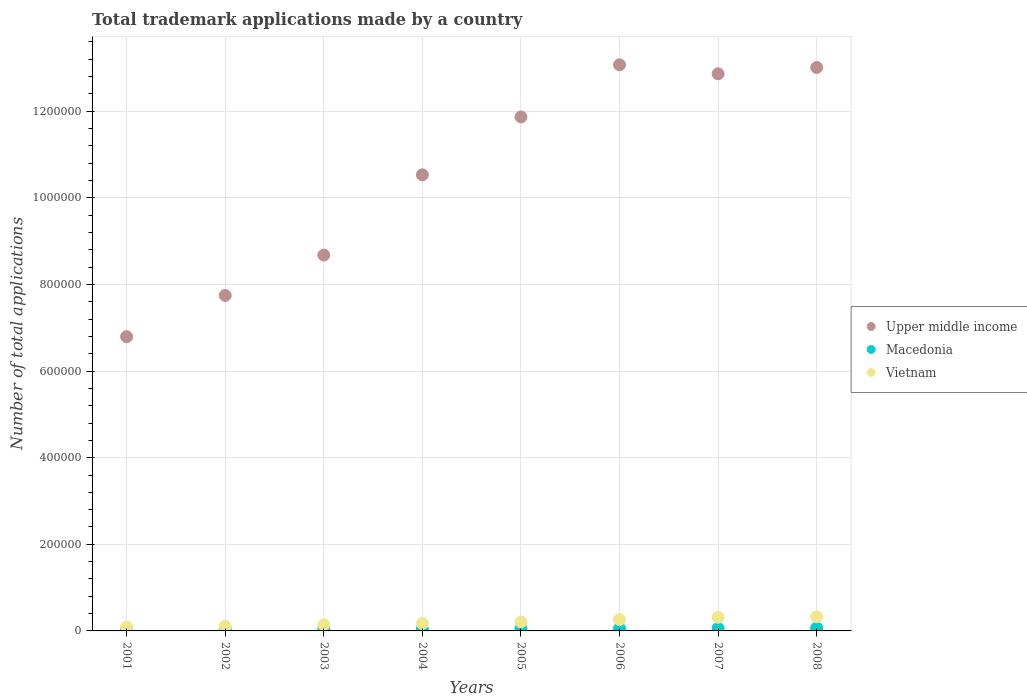How many different coloured dotlines are there?
Your answer should be very brief. 3. What is the number of applications made by in Upper middle income in 2001?
Give a very brief answer. 6.79e+05. Across all years, what is the maximum number of applications made by in Macedonia?
Offer a terse response. 6856. Across all years, what is the minimum number of applications made by in Macedonia?
Offer a very short reply. 3952. In which year was the number of applications made by in Vietnam maximum?
Keep it short and to the point. 2008. What is the total number of applications made by in Upper middle income in the graph?
Make the answer very short. 8.46e+06. What is the difference between the number of applications made by in Upper middle income in 2002 and that in 2003?
Offer a terse response. -9.32e+04. What is the difference between the number of applications made by in Macedonia in 2006 and the number of applications made by in Upper middle income in 2004?
Make the answer very short. -1.05e+06. What is the average number of applications made by in Macedonia per year?
Offer a terse response. 5102.62. In the year 2006, what is the difference between the number of applications made by in Macedonia and number of applications made by in Upper middle income?
Your response must be concise. -1.30e+06. What is the ratio of the number of applications made by in Vietnam in 2001 to that in 2005?
Your answer should be very brief. 0.42. Is the number of applications made by in Macedonia in 2001 less than that in 2006?
Provide a short and direct response. Yes. What is the difference between the highest and the second highest number of applications made by in Macedonia?
Make the answer very short. 905. What is the difference between the highest and the lowest number of applications made by in Macedonia?
Give a very brief answer. 2904. In how many years, is the number of applications made by in Vietnam greater than the average number of applications made by in Vietnam taken over all years?
Offer a terse response. 4. Is the number of applications made by in Upper middle income strictly greater than the number of applications made by in Macedonia over the years?
Give a very brief answer. Yes. How many years are there in the graph?
Your response must be concise. 8. Are the values on the major ticks of Y-axis written in scientific E-notation?
Offer a terse response. No. Does the graph contain any zero values?
Give a very brief answer. No. How many legend labels are there?
Offer a terse response. 3. What is the title of the graph?
Your answer should be compact. Total trademark applications made by a country. Does "Philippines" appear as one of the legend labels in the graph?
Give a very brief answer. No. What is the label or title of the Y-axis?
Offer a very short reply. Number of total applications. What is the Number of total applications in Upper middle income in 2001?
Your response must be concise. 6.79e+05. What is the Number of total applications of Macedonia in 2001?
Your answer should be compact. 4402. What is the Number of total applications of Vietnam in 2001?
Make the answer very short. 8767. What is the Number of total applications in Upper middle income in 2002?
Provide a succinct answer. 7.75e+05. What is the Number of total applications of Macedonia in 2002?
Give a very brief answer. 3952. What is the Number of total applications of Vietnam in 2002?
Provide a short and direct response. 1.07e+04. What is the Number of total applications in Upper middle income in 2003?
Offer a terse response. 8.68e+05. What is the Number of total applications of Macedonia in 2003?
Provide a succinct answer. 4346. What is the Number of total applications of Vietnam in 2003?
Your answer should be compact. 1.42e+04. What is the Number of total applications of Upper middle income in 2004?
Make the answer very short. 1.05e+06. What is the Number of total applications in Macedonia in 2004?
Keep it short and to the point. 4402. What is the Number of total applications of Vietnam in 2004?
Offer a very short reply. 1.72e+04. What is the Number of total applications in Upper middle income in 2005?
Keep it short and to the point. 1.19e+06. What is the Number of total applications in Macedonia in 2005?
Give a very brief answer. 5397. What is the Number of total applications of Vietnam in 2005?
Give a very brief answer. 2.07e+04. What is the Number of total applications of Upper middle income in 2006?
Keep it short and to the point. 1.31e+06. What is the Number of total applications of Macedonia in 2006?
Offer a very short reply. 5515. What is the Number of total applications of Vietnam in 2006?
Provide a succinct answer. 2.61e+04. What is the Number of total applications of Upper middle income in 2007?
Give a very brief answer. 1.29e+06. What is the Number of total applications in Macedonia in 2007?
Give a very brief answer. 5951. What is the Number of total applications of Vietnam in 2007?
Keep it short and to the point. 3.15e+04. What is the Number of total applications of Upper middle income in 2008?
Offer a terse response. 1.30e+06. What is the Number of total applications of Macedonia in 2008?
Ensure brevity in your answer.  6856. What is the Number of total applications of Vietnam in 2008?
Give a very brief answer. 3.27e+04. Across all years, what is the maximum Number of total applications of Upper middle income?
Your answer should be very brief. 1.31e+06. Across all years, what is the maximum Number of total applications of Macedonia?
Your answer should be very brief. 6856. Across all years, what is the maximum Number of total applications in Vietnam?
Provide a succinct answer. 3.27e+04. Across all years, what is the minimum Number of total applications of Upper middle income?
Your answer should be compact. 6.79e+05. Across all years, what is the minimum Number of total applications in Macedonia?
Make the answer very short. 3952. Across all years, what is the minimum Number of total applications in Vietnam?
Ensure brevity in your answer.  8767. What is the total Number of total applications in Upper middle income in the graph?
Offer a terse response. 8.46e+06. What is the total Number of total applications in Macedonia in the graph?
Make the answer very short. 4.08e+04. What is the total Number of total applications of Vietnam in the graph?
Your response must be concise. 1.62e+05. What is the difference between the Number of total applications in Upper middle income in 2001 and that in 2002?
Offer a terse response. -9.53e+04. What is the difference between the Number of total applications of Macedonia in 2001 and that in 2002?
Ensure brevity in your answer.  450. What is the difference between the Number of total applications of Vietnam in 2001 and that in 2002?
Your answer should be compact. -1980. What is the difference between the Number of total applications of Upper middle income in 2001 and that in 2003?
Give a very brief answer. -1.88e+05. What is the difference between the Number of total applications of Macedonia in 2001 and that in 2003?
Make the answer very short. 56. What is the difference between the Number of total applications in Vietnam in 2001 and that in 2003?
Your answer should be very brief. -5436. What is the difference between the Number of total applications of Upper middle income in 2001 and that in 2004?
Provide a succinct answer. -3.74e+05. What is the difference between the Number of total applications in Macedonia in 2001 and that in 2004?
Offer a terse response. 0. What is the difference between the Number of total applications in Vietnam in 2001 and that in 2004?
Your answer should be very brief. -8408. What is the difference between the Number of total applications in Upper middle income in 2001 and that in 2005?
Your response must be concise. -5.07e+05. What is the difference between the Number of total applications of Macedonia in 2001 and that in 2005?
Make the answer very short. -995. What is the difference between the Number of total applications in Vietnam in 2001 and that in 2005?
Keep it short and to the point. -1.19e+04. What is the difference between the Number of total applications of Upper middle income in 2001 and that in 2006?
Keep it short and to the point. -6.28e+05. What is the difference between the Number of total applications in Macedonia in 2001 and that in 2006?
Your response must be concise. -1113. What is the difference between the Number of total applications in Vietnam in 2001 and that in 2006?
Make the answer very short. -1.74e+04. What is the difference between the Number of total applications in Upper middle income in 2001 and that in 2007?
Give a very brief answer. -6.07e+05. What is the difference between the Number of total applications of Macedonia in 2001 and that in 2007?
Provide a short and direct response. -1549. What is the difference between the Number of total applications in Vietnam in 2001 and that in 2007?
Make the answer very short. -2.27e+04. What is the difference between the Number of total applications in Upper middle income in 2001 and that in 2008?
Provide a short and direct response. -6.22e+05. What is the difference between the Number of total applications in Macedonia in 2001 and that in 2008?
Your response must be concise. -2454. What is the difference between the Number of total applications in Vietnam in 2001 and that in 2008?
Offer a terse response. -2.39e+04. What is the difference between the Number of total applications of Upper middle income in 2002 and that in 2003?
Offer a terse response. -9.32e+04. What is the difference between the Number of total applications of Macedonia in 2002 and that in 2003?
Your response must be concise. -394. What is the difference between the Number of total applications in Vietnam in 2002 and that in 2003?
Your answer should be compact. -3456. What is the difference between the Number of total applications of Upper middle income in 2002 and that in 2004?
Provide a succinct answer. -2.78e+05. What is the difference between the Number of total applications of Macedonia in 2002 and that in 2004?
Offer a very short reply. -450. What is the difference between the Number of total applications of Vietnam in 2002 and that in 2004?
Give a very brief answer. -6428. What is the difference between the Number of total applications in Upper middle income in 2002 and that in 2005?
Your response must be concise. -4.12e+05. What is the difference between the Number of total applications in Macedonia in 2002 and that in 2005?
Make the answer very short. -1445. What is the difference between the Number of total applications of Vietnam in 2002 and that in 2005?
Offer a terse response. -9916. What is the difference between the Number of total applications in Upper middle income in 2002 and that in 2006?
Offer a very short reply. -5.33e+05. What is the difference between the Number of total applications of Macedonia in 2002 and that in 2006?
Ensure brevity in your answer.  -1563. What is the difference between the Number of total applications in Vietnam in 2002 and that in 2006?
Offer a very short reply. -1.54e+04. What is the difference between the Number of total applications in Upper middle income in 2002 and that in 2007?
Provide a short and direct response. -5.12e+05. What is the difference between the Number of total applications of Macedonia in 2002 and that in 2007?
Offer a very short reply. -1999. What is the difference between the Number of total applications of Vietnam in 2002 and that in 2007?
Make the answer very short. -2.08e+04. What is the difference between the Number of total applications in Upper middle income in 2002 and that in 2008?
Make the answer very short. -5.26e+05. What is the difference between the Number of total applications of Macedonia in 2002 and that in 2008?
Your response must be concise. -2904. What is the difference between the Number of total applications of Vietnam in 2002 and that in 2008?
Offer a very short reply. -2.19e+04. What is the difference between the Number of total applications in Upper middle income in 2003 and that in 2004?
Your answer should be compact. -1.85e+05. What is the difference between the Number of total applications of Macedonia in 2003 and that in 2004?
Provide a short and direct response. -56. What is the difference between the Number of total applications in Vietnam in 2003 and that in 2004?
Give a very brief answer. -2972. What is the difference between the Number of total applications in Upper middle income in 2003 and that in 2005?
Keep it short and to the point. -3.19e+05. What is the difference between the Number of total applications of Macedonia in 2003 and that in 2005?
Keep it short and to the point. -1051. What is the difference between the Number of total applications of Vietnam in 2003 and that in 2005?
Ensure brevity in your answer.  -6460. What is the difference between the Number of total applications in Upper middle income in 2003 and that in 2006?
Offer a terse response. -4.39e+05. What is the difference between the Number of total applications in Macedonia in 2003 and that in 2006?
Provide a succinct answer. -1169. What is the difference between the Number of total applications in Vietnam in 2003 and that in 2006?
Your answer should be very brief. -1.19e+04. What is the difference between the Number of total applications in Upper middle income in 2003 and that in 2007?
Offer a terse response. -4.19e+05. What is the difference between the Number of total applications in Macedonia in 2003 and that in 2007?
Your response must be concise. -1605. What is the difference between the Number of total applications in Vietnam in 2003 and that in 2007?
Offer a very short reply. -1.73e+04. What is the difference between the Number of total applications of Upper middle income in 2003 and that in 2008?
Provide a short and direct response. -4.33e+05. What is the difference between the Number of total applications in Macedonia in 2003 and that in 2008?
Your answer should be very brief. -2510. What is the difference between the Number of total applications of Vietnam in 2003 and that in 2008?
Your answer should be very brief. -1.85e+04. What is the difference between the Number of total applications of Upper middle income in 2004 and that in 2005?
Give a very brief answer. -1.34e+05. What is the difference between the Number of total applications of Macedonia in 2004 and that in 2005?
Offer a very short reply. -995. What is the difference between the Number of total applications of Vietnam in 2004 and that in 2005?
Give a very brief answer. -3488. What is the difference between the Number of total applications of Upper middle income in 2004 and that in 2006?
Give a very brief answer. -2.54e+05. What is the difference between the Number of total applications of Macedonia in 2004 and that in 2006?
Make the answer very short. -1113. What is the difference between the Number of total applications of Vietnam in 2004 and that in 2006?
Make the answer very short. -8965. What is the difference between the Number of total applications of Upper middle income in 2004 and that in 2007?
Your answer should be very brief. -2.33e+05. What is the difference between the Number of total applications of Macedonia in 2004 and that in 2007?
Make the answer very short. -1549. What is the difference between the Number of total applications in Vietnam in 2004 and that in 2007?
Make the answer very short. -1.43e+04. What is the difference between the Number of total applications in Upper middle income in 2004 and that in 2008?
Your answer should be very brief. -2.48e+05. What is the difference between the Number of total applications in Macedonia in 2004 and that in 2008?
Your answer should be compact. -2454. What is the difference between the Number of total applications of Vietnam in 2004 and that in 2008?
Your answer should be compact. -1.55e+04. What is the difference between the Number of total applications in Upper middle income in 2005 and that in 2006?
Offer a terse response. -1.20e+05. What is the difference between the Number of total applications in Macedonia in 2005 and that in 2006?
Offer a terse response. -118. What is the difference between the Number of total applications in Vietnam in 2005 and that in 2006?
Offer a terse response. -5477. What is the difference between the Number of total applications in Upper middle income in 2005 and that in 2007?
Offer a very short reply. -9.96e+04. What is the difference between the Number of total applications of Macedonia in 2005 and that in 2007?
Ensure brevity in your answer.  -554. What is the difference between the Number of total applications in Vietnam in 2005 and that in 2007?
Your answer should be very brief. -1.08e+04. What is the difference between the Number of total applications in Upper middle income in 2005 and that in 2008?
Keep it short and to the point. -1.14e+05. What is the difference between the Number of total applications in Macedonia in 2005 and that in 2008?
Provide a succinct answer. -1459. What is the difference between the Number of total applications in Vietnam in 2005 and that in 2008?
Ensure brevity in your answer.  -1.20e+04. What is the difference between the Number of total applications in Upper middle income in 2006 and that in 2007?
Your answer should be very brief. 2.08e+04. What is the difference between the Number of total applications in Macedonia in 2006 and that in 2007?
Ensure brevity in your answer.  -436. What is the difference between the Number of total applications of Vietnam in 2006 and that in 2007?
Offer a terse response. -5357. What is the difference between the Number of total applications of Upper middle income in 2006 and that in 2008?
Offer a terse response. 6140. What is the difference between the Number of total applications in Macedonia in 2006 and that in 2008?
Your answer should be very brief. -1341. What is the difference between the Number of total applications of Vietnam in 2006 and that in 2008?
Your response must be concise. -6544. What is the difference between the Number of total applications in Upper middle income in 2007 and that in 2008?
Offer a terse response. -1.46e+04. What is the difference between the Number of total applications in Macedonia in 2007 and that in 2008?
Ensure brevity in your answer.  -905. What is the difference between the Number of total applications of Vietnam in 2007 and that in 2008?
Offer a terse response. -1187. What is the difference between the Number of total applications of Upper middle income in 2001 and the Number of total applications of Macedonia in 2002?
Provide a short and direct response. 6.75e+05. What is the difference between the Number of total applications in Upper middle income in 2001 and the Number of total applications in Vietnam in 2002?
Ensure brevity in your answer.  6.69e+05. What is the difference between the Number of total applications of Macedonia in 2001 and the Number of total applications of Vietnam in 2002?
Provide a short and direct response. -6345. What is the difference between the Number of total applications in Upper middle income in 2001 and the Number of total applications in Macedonia in 2003?
Ensure brevity in your answer.  6.75e+05. What is the difference between the Number of total applications in Upper middle income in 2001 and the Number of total applications in Vietnam in 2003?
Offer a terse response. 6.65e+05. What is the difference between the Number of total applications in Macedonia in 2001 and the Number of total applications in Vietnam in 2003?
Offer a terse response. -9801. What is the difference between the Number of total applications in Upper middle income in 2001 and the Number of total applications in Macedonia in 2004?
Keep it short and to the point. 6.75e+05. What is the difference between the Number of total applications in Upper middle income in 2001 and the Number of total applications in Vietnam in 2004?
Offer a very short reply. 6.62e+05. What is the difference between the Number of total applications of Macedonia in 2001 and the Number of total applications of Vietnam in 2004?
Give a very brief answer. -1.28e+04. What is the difference between the Number of total applications in Upper middle income in 2001 and the Number of total applications in Macedonia in 2005?
Keep it short and to the point. 6.74e+05. What is the difference between the Number of total applications of Upper middle income in 2001 and the Number of total applications of Vietnam in 2005?
Offer a terse response. 6.59e+05. What is the difference between the Number of total applications of Macedonia in 2001 and the Number of total applications of Vietnam in 2005?
Ensure brevity in your answer.  -1.63e+04. What is the difference between the Number of total applications in Upper middle income in 2001 and the Number of total applications in Macedonia in 2006?
Give a very brief answer. 6.74e+05. What is the difference between the Number of total applications of Upper middle income in 2001 and the Number of total applications of Vietnam in 2006?
Provide a short and direct response. 6.53e+05. What is the difference between the Number of total applications in Macedonia in 2001 and the Number of total applications in Vietnam in 2006?
Provide a short and direct response. -2.17e+04. What is the difference between the Number of total applications in Upper middle income in 2001 and the Number of total applications in Macedonia in 2007?
Your answer should be very brief. 6.73e+05. What is the difference between the Number of total applications of Upper middle income in 2001 and the Number of total applications of Vietnam in 2007?
Give a very brief answer. 6.48e+05. What is the difference between the Number of total applications in Macedonia in 2001 and the Number of total applications in Vietnam in 2007?
Your response must be concise. -2.71e+04. What is the difference between the Number of total applications of Upper middle income in 2001 and the Number of total applications of Macedonia in 2008?
Your response must be concise. 6.73e+05. What is the difference between the Number of total applications in Upper middle income in 2001 and the Number of total applications in Vietnam in 2008?
Ensure brevity in your answer.  6.47e+05. What is the difference between the Number of total applications of Macedonia in 2001 and the Number of total applications of Vietnam in 2008?
Keep it short and to the point. -2.83e+04. What is the difference between the Number of total applications in Upper middle income in 2002 and the Number of total applications in Macedonia in 2003?
Your answer should be compact. 7.70e+05. What is the difference between the Number of total applications of Upper middle income in 2002 and the Number of total applications of Vietnam in 2003?
Ensure brevity in your answer.  7.60e+05. What is the difference between the Number of total applications in Macedonia in 2002 and the Number of total applications in Vietnam in 2003?
Provide a succinct answer. -1.03e+04. What is the difference between the Number of total applications in Upper middle income in 2002 and the Number of total applications in Macedonia in 2004?
Keep it short and to the point. 7.70e+05. What is the difference between the Number of total applications of Upper middle income in 2002 and the Number of total applications of Vietnam in 2004?
Provide a succinct answer. 7.57e+05. What is the difference between the Number of total applications in Macedonia in 2002 and the Number of total applications in Vietnam in 2004?
Provide a succinct answer. -1.32e+04. What is the difference between the Number of total applications in Upper middle income in 2002 and the Number of total applications in Macedonia in 2005?
Provide a short and direct response. 7.69e+05. What is the difference between the Number of total applications of Upper middle income in 2002 and the Number of total applications of Vietnam in 2005?
Your answer should be very brief. 7.54e+05. What is the difference between the Number of total applications in Macedonia in 2002 and the Number of total applications in Vietnam in 2005?
Keep it short and to the point. -1.67e+04. What is the difference between the Number of total applications of Upper middle income in 2002 and the Number of total applications of Macedonia in 2006?
Your answer should be very brief. 7.69e+05. What is the difference between the Number of total applications in Upper middle income in 2002 and the Number of total applications in Vietnam in 2006?
Keep it short and to the point. 7.49e+05. What is the difference between the Number of total applications of Macedonia in 2002 and the Number of total applications of Vietnam in 2006?
Ensure brevity in your answer.  -2.22e+04. What is the difference between the Number of total applications of Upper middle income in 2002 and the Number of total applications of Macedonia in 2007?
Your response must be concise. 7.69e+05. What is the difference between the Number of total applications of Upper middle income in 2002 and the Number of total applications of Vietnam in 2007?
Your answer should be compact. 7.43e+05. What is the difference between the Number of total applications of Macedonia in 2002 and the Number of total applications of Vietnam in 2007?
Your response must be concise. -2.75e+04. What is the difference between the Number of total applications of Upper middle income in 2002 and the Number of total applications of Macedonia in 2008?
Give a very brief answer. 7.68e+05. What is the difference between the Number of total applications in Upper middle income in 2002 and the Number of total applications in Vietnam in 2008?
Keep it short and to the point. 7.42e+05. What is the difference between the Number of total applications of Macedonia in 2002 and the Number of total applications of Vietnam in 2008?
Your answer should be compact. -2.87e+04. What is the difference between the Number of total applications in Upper middle income in 2003 and the Number of total applications in Macedonia in 2004?
Your answer should be compact. 8.63e+05. What is the difference between the Number of total applications of Upper middle income in 2003 and the Number of total applications of Vietnam in 2004?
Give a very brief answer. 8.51e+05. What is the difference between the Number of total applications of Macedonia in 2003 and the Number of total applications of Vietnam in 2004?
Keep it short and to the point. -1.28e+04. What is the difference between the Number of total applications of Upper middle income in 2003 and the Number of total applications of Macedonia in 2005?
Keep it short and to the point. 8.62e+05. What is the difference between the Number of total applications of Upper middle income in 2003 and the Number of total applications of Vietnam in 2005?
Give a very brief answer. 8.47e+05. What is the difference between the Number of total applications in Macedonia in 2003 and the Number of total applications in Vietnam in 2005?
Offer a terse response. -1.63e+04. What is the difference between the Number of total applications in Upper middle income in 2003 and the Number of total applications in Macedonia in 2006?
Give a very brief answer. 8.62e+05. What is the difference between the Number of total applications in Upper middle income in 2003 and the Number of total applications in Vietnam in 2006?
Your response must be concise. 8.42e+05. What is the difference between the Number of total applications in Macedonia in 2003 and the Number of total applications in Vietnam in 2006?
Your response must be concise. -2.18e+04. What is the difference between the Number of total applications in Upper middle income in 2003 and the Number of total applications in Macedonia in 2007?
Provide a short and direct response. 8.62e+05. What is the difference between the Number of total applications in Upper middle income in 2003 and the Number of total applications in Vietnam in 2007?
Ensure brevity in your answer.  8.36e+05. What is the difference between the Number of total applications of Macedonia in 2003 and the Number of total applications of Vietnam in 2007?
Keep it short and to the point. -2.72e+04. What is the difference between the Number of total applications of Upper middle income in 2003 and the Number of total applications of Macedonia in 2008?
Offer a terse response. 8.61e+05. What is the difference between the Number of total applications of Upper middle income in 2003 and the Number of total applications of Vietnam in 2008?
Offer a very short reply. 8.35e+05. What is the difference between the Number of total applications of Macedonia in 2003 and the Number of total applications of Vietnam in 2008?
Your response must be concise. -2.83e+04. What is the difference between the Number of total applications in Upper middle income in 2004 and the Number of total applications in Macedonia in 2005?
Ensure brevity in your answer.  1.05e+06. What is the difference between the Number of total applications in Upper middle income in 2004 and the Number of total applications in Vietnam in 2005?
Offer a very short reply. 1.03e+06. What is the difference between the Number of total applications in Macedonia in 2004 and the Number of total applications in Vietnam in 2005?
Offer a terse response. -1.63e+04. What is the difference between the Number of total applications in Upper middle income in 2004 and the Number of total applications in Macedonia in 2006?
Ensure brevity in your answer.  1.05e+06. What is the difference between the Number of total applications in Upper middle income in 2004 and the Number of total applications in Vietnam in 2006?
Provide a succinct answer. 1.03e+06. What is the difference between the Number of total applications of Macedonia in 2004 and the Number of total applications of Vietnam in 2006?
Offer a very short reply. -2.17e+04. What is the difference between the Number of total applications of Upper middle income in 2004 and the Number of total applications of Macedonia in 2007?
Offer a terse response. 1.05e+06. What is the difference between the Number of total applications of Upper middle income in 2004 and the Number of total applications of Vietnam in 2007?
Offer a terse response. 1.02e+06. What is the difference between the Number of total applications of Macedonia in 2004 and the Number of total applications of Vietnam in 2007?
Give a very brief answer. -2.71e+04. What is the difference between the Number of total applications in Upper middle income in 2004 and the Number of total applications in Macedonia in 2008?
Keep it short and to the point. 1.05e+06. What is the difference between the Number of total applications of Upper middle income in 2004 and the Number of total applications of Vietnam in 2008?
Offer a terse response. 1.02e+06. What is the difference between the Number of total applications of Macedonia in 2004 and the Number of total applications of Vietnam in 2008?
Ensure brevity in your answer.  -2.83e+04. What is the difference between the Number of total applications in Upper middle income in 2005 and the Number of total applications in Macedonia in 2006?
Your answer should be compact. 1.18e+06. What is the difference between the Number of total applications in Upper middle income in 2005 and the Number of total applications in Vietnam in 2006?
Provide a short and direct response. 1.16e+06. What is the difference between the Number of total applications of Macedonia in 2005 and the Number of total applications of Vietnam in 2006?
Give a very brief answer. -2.07e+04. What is the difference between the Number of total applications in Upper middle income in 2005 and the Number of total applications in Macedonia in 2007?
Keep it short and to the point. 1.18e+06. What is the difference between the Number of total applications of Upper middle income in 2005 and the Number of total applications of Vietnam in 2007?
Your answer should be compact. 1.16e+06. What is the difference between the Number of total applications in Macedonia in 2005 and the Number of total applications in Vietnam in 2007?
Provide a short and direct response. -2.61e+04. What is the difference between the Number of total applications of Upper middle income in 2005 and the Number of total applications of Macedonia in 2008?
Offer a very short reply. 1.18e+06. What is the difference between the Number of total applications of Upper middle income in 2005 and the Number of total applications of Vietnam in 2008?
Offer a terse response. 1.15e+06. What is the difference between the Number of total applications of Macedonia in 2005 and the Number of total applications of Vietnam in 2008?
Your answer should be very brief. -2.73e+04. What is the difference between the Number of total applications in Upper middle income in 2006 and the Number of total applications in Macedonia in 2007?
Offer a very short reply. 1.30e+06. What is the difference between the Number of total applications in Upper middle income in 2006 and the Number of total applications in Vietnam in 2007?
Offer a terse response. 1.28e+06. What is the difference between the Number of total applications of Macedonia in 2006 and the Number of total applications of Vietnam in 2007?
Your answer should be compact. -2.60e+04. What is the difference between the Number of total applications in Upper middle income in 2006 and the Number of total applications in Macedonia in 2008?
Your response must be concise. 1.30e+06. What is the difference between the Number of total applications of Upper middle income in 2006 and the Number of total applications of Vietnam in 2008?
Offer a terse response. 1.27e+06. What is the difference between the Number of total applications of Macedonia in 2006 and the Number of total applications of Vietnam in 2008?
Keep it short and to the point. -2.72e+04. What is the difference between the Number of total applications of Upper middle income in 2007 and the Number of total applications of Macedonia in 2008?
Make the answer very short. 1.28e+06. What is the difference between the Number of total applications of Upper middle income in 2007 and the Number of total applications of Vietnam in 2008?
Provide a short and direct response. 1.25e+06. What is the difference between the Number of total applications in Macedonia in 2007 and the Number of total applications in Vietnam in 2008?
Make the answer very short. -2.67e+04. What is the average Number of total applications in Upper middle income per year?
Offer a terse response. 1.06e+06. What is the average Number of total applications of Macedonia per year?
Give a very brief answer. 5102.62. What is the average Number of total applications of Vietnam per year?
Ensure brevity in your answer.  2.02e+04. In the year 2001, what is the difference between the Number of total applications of Upper middle income and Number of total applications of Macedonia?
Ensure brevity in your answer.  6.75e+05. In the year 2001, what is the difference between the Number of total applications in Upper middle income and Number of total applications in Vietnam?
Make the answer very short. 6.71e+05. In the year 2001, what is the difference between the Number of total applications of Macedonia and Number of total applications of Vietnam?
Give a very brief answer. -4365. In the year 2002, what is the difference between the Number of total applications in Upper middle income and Number of total applications in Macedonia?
Make the answer very short. 7.71e+05. In the year 2002, what is the difference between the Number of total applications of Upper middle income and Number of total applications of Vietnam?
Offer a terse response. 7.64e+05. In the year 2002, what is the difference between the Number of total applications in Macedonia and Number of total applications in Vietnam?
Provide a succinct answer. -6795. In the year 2003, what is the difference between the Number of total applications of Upper middle income and Number of total applications of Macedonia?
Offer a terse response. 8.63e+05. In the year 2003, what is the difference between the Number of total applications in Upper middle income and Number of total applications in Vietnam?
Make the answer very short. 8.54e+05. In the year 2003, what is the difference between the Number of total applications in Macedonia and Number of total applications in Vietnam?
Keep it short and to the point. -9857. In the year 2004, what is the difference between the Number of total applications of Upper middle income and Number of total applications of Macedonia?
Make the answer very short. 1.05e+06. In the year 2004, what is the difference between the Number of total applications in Upper middle income and Number of total applications in Vietnam?
Make the answer very short. 1.04e+06. In the year 2004, what is the difference between the Number of total applications in Macedonia and Number of total applications in Vietnam?
Offer a terse response. -1.28e+04. In the year 2005, what is the difference between the Number of total applications of Upper middle income and Number of total applications of Macedonia?
Make the answer very short. 1.18e+06. In the year 2005, what is the difference between the Number of total applications in Upper middle income and Number of total applications in Vietnam?
Your response must be concise. 1.17e+06. In the year 2005, what is the difference between the Number of total applications in Macedonia and Number of total applications in Vietnam?
Make the answer very short. -1.53e+04. In the year 2006, what is the difference between the Number of total applications in Upper middle income and Number of total applications in Macedonia?
Ensure brevity in your answer.  1.30e+06. In the year 2006, what is the difference between the Number of total applications in Upper middle income and Number of total applications in Vietnam?
Give a very brief answer. 1.28e+06. In the year 2006, what is the difference between the Number of total applications of Macedonia and Number of total applications of Vietnam?
Keep it short and to the point. -2.06e+04. In the year 2007, what is the difference between the Number of total applications in Upper middle income and Number of total applications in Macedonia?
Offer a terse response. 1.28e+06. In the year 2007, what is the difference between the Number of total applications of Upper middle income and Number of total applications of Vietnam?
Make the answer very short. 1.25e+06. In the year 2007, what is the difference between the Number of total applications in Macedonia and Number of total applications in Vietnam?
Make the answer very short. -2.55e+04. In the year 2008, what is the difference between the Number of total applications of Upper middle income and Number of total applications of Macedonia?
Your answer should be very brief. 1.29e+06. In the year 2008, what is the difference between the Number of total applications of Upper middle income and Number of total applications of Vietnam?
Your answer should be very brief. 1.27e+06. In the year 2008, what is the difference between the Number of total applications of Macedonia and Number of total applications of Vietnam?
Give a very brief answer. -2.58e+04. What is the ratio of the Number of total applications of Upper middle income in 2001 to that in 2002?
Make the answer very short. 0.88. What is the ratio of the Number of total applications of Macedonia in 2001 to that in 2002?
Provide a succinct answer. 1.11. What is the ratio of the Number of total applications of Vietnam in 2001 to that in 2002?
Ensure brevity in your answer.  0.82. What is the ratio of the Number of total applications in Upper middle income in 2001 to that in 2003?
Offer a terse response. 0.78. What is the ratio of the Number of total applications in Macedonia in 2001 to that in 2003?
Provide a succinct answer. 1.01. What is the ratio of the Number of total applications in Vietnam in 2001 to that in 2003?
Make the answer very short. 0.62. What is the ratio of the Number of total applications in Upper middle income in 2001 to that in 2004?
Provide a short and direct response. 0.65. What is the ratio of the Number of total applications in Macedonia in 2001 to that in 2004?
Offer a terse response. 1. What is the ratio of the Number of total applications of Vietnam in 2001 to that in 2004?
Keep it short and to the point. 0.51. What is the ratio of the Number of total applications in Upper middle income in 2001 to that in 2005?
Provide a short and direct response. 0.57. What is the ratio of the Number of total applications of Macedonia in 2001 to that in 2005?
Provide a short and direct response. 0.82. What is the ratio of the Number of total applications of Vietnam in 2001 to that in 2005?
Offer a very short reply. 0.42. What is the ratio of the Number of total applications of Upper middle income in 2001 to that in 2006?
Make the answer very short. 0.52. What is the ratio of the Number of total applications of Macedonia in 2001 to that in 2006?
Your answer should be compact. 0.8. What is the ratio of the Number of total applications of Vietnam in 2001 to that in 2006?
Offer a very short reply. 0.34. What is the ratio of the Number of total applications in Upper middle income in 2001 to that in 2007?
Give a very brief answer. 0.53. What is the ratio of the Number of total applications of Macedonia in 2001 to that in 2007?
Your answer should be compact. 0.74. What is the ratio of the Number of total applications of Vietnam in 2001 to that in 2007?
Your response must be concise. 0.28. What is the ratio of the Number of total applications of Upper middle income in 2001 to that in 2008?
Your response must be concise. 0.52. What is the ratio of the Number of total applications in Macedonia in 2001 to that in 2008?
Offer a very short reply. 0.64. What is the ratio of the Number of total applications of Vietnam in 2001 to that in 2008?
Your answer should be compact. 0.27. What is the ratio of the Number of total applications of Upper middle income in 2002 to that in 2003?
Offer a very short reply. 0.89. What is the ratio of the Number of total applications in Macedonia in 2002 to that in 2003?
Offer a terse response. 0.91. What is the ratio of the Number of total applications of Vietnam in 2002 to that in 2003?
Provide a short and direct response. 0.76. What is the ratio of the Number of total applications of Upper middle income in 2002 to that in 2004?
Your answer should be very brief. 0.74. What is the ratio of the Number of total applications in Macedonia in 2002 to that in 2004?
Your answer should be very brief. 0.9. What is the ratio of the Number of total applications of Vietnam in 2002 to that in 2004?
Your response must be concise. 0.63. What is the ratio of the Number of total applications of Upper middle income in 2002 to that in 2005?
Offer a very short reply. 0.65. What is the ratio of the Number of total applications of Macedonia in 2002 to that in 2005?
Keep it short and to the point. 0.73. What is the ratio of the Number of total applications of Vietnam in 2002 to that in 2005?
Your answer should be compact. 0.52. What is the ratio of the Number of total applications of Upper middle income in 2002 to that in 2006?
Make the answer very short. 0.59. What is the ratio of the Number of total applications of Macedonia in 2002 to that in 2006?
Your answer should be compact. 0.72. What is the ratio of the Number of total applications in Vietnam in 2002 to that in 2006?
Offer a terse response. 0.41. What is the ratio of the Number of total applications in Upper middle income in 2002 to that in 2007?
Your answer should be very brief. 0.6. What is the ratio of the Number of total applications in Macedonia in 2002 to that in 2007?
Your response must be concise. 0.66. What is the ratio of the Number of total applications in Vietnam in 2002 to that in 2007?
Provide a short and direct response. 0.34. What is the ratio of the Number of total applications of Upper middle income in 2002 to that in 2008?
Your response must be concise. 0.6. What is the ratio of the Number of total applications in Macedonia in 2002 to that in 2008?
Offer a very short reply. 0.58. What is the ratio of the Number of total applications in Vietnam in 2002 to that in 2008?
Provide a short and direct response. 0.33. What is the ratio of the Number of total applications of Upper middle income in 2003 to that in 2004?
Make the answer very short. 0.82. What is the ratio of the Number of total applications in Macedonia in 2003 to that in 2004?
Offer a terse response. 0.99. What is the ratio of the Number of total applications in Vietnam in 2003 to that in 2004?
Your response must be concise. 0.83. What is the ratio of the Number of total applications in Upper middle income in 2003 to that in 2005?
Offer a terse response. 0.73. What is the ratio of the Number of total applications of Macedonia in 2003 to that in 2005?
Make the answer very short. 0.81. What is the ratio of the Number of total applications of Vietnam in 2003 to that in 2005?
Make the answer very short. 0.69. What is the ratio of the Number of total applications of Upper middle income in 2003 to that in 2006?
Provide a short and direct response. 0.66. What is the ratio of the Number of total applications of Macedonia in 2003 to that in 2006?
Offer a terse response. 0.79. What is the ratio of the Number of total applications in Vietnam in 2003 to that in 2006?
Offer a terse response. 0.54. What is the ratio of the Number of total applications of Upper middle income in 2003 to that in 2007?
Your response must be concise. 0.67. What is the ratio of the Number of total applications of Macedonia in 2003 to that in 2007?
Offer a terse response. 0.73. What is the ratio of the Number of total applications in Vietnam in 2003 to that in 2007?
Keep it short and to the point. 0.45. What is the ratio of the Number of total applications in Upper middle income in 2003 to that in 2008?
Your response must be concise. 0.67. What is the ratio of the Number of total applications of Macedonia in 2003 to that in 2008?
Provide a short and direct response. 0.63. What is the ratio of the Number of total applications of Vietnam in 2003 to that in 2008?
Give a very brief answer. 0.43. What is the ratio of the Number of total applications of Upper middle income in 2004 to that in 2005?
Your response must be concise. 0.89. What is the ratio of the Number of total applications in Macedonia in 2004 to that in 2005?
Provide a short and direct response. 0.82. What is the ratio of the Number of total applications in Vietnam in 2004 to that in 2005?
Offer a terse response. 0.83. What is the ratio of the Number of total applications of Upper middle income in 2004 to that in 2006?
Provide a succinct answer. 0.81. What is the ratio of the Number of total applications of Macedonia in 2004 to that in 2006?
Your answer should be very brief. 0.8. What is the ratio of the Number of total applications in Vietnam in 2004 to that in 2006?
Ensure brevity in your answer.  0.66. What is the ratio of the Number of total applications of Upper middle income in 2004 to that in 2007?
Keep it short and to the point. 0.82. What is the ratio of the Number of total applications of Macedonia in 2004 to that in 2007?
Your answer should be very brief. 0.74. What is the ratio of the Number of total applications of Vietnam in 2004 to that in 2007?
Give a very brief answer. 0.55. What is the ratio of the Number of total applications of Upper middle income in 2004 to that in 2008?
Keep it short and to the point. 0.81. What is the ratio of the Number of total applications of Macedonia in 2004 to that in 2008?
Your answer should be very brief. 0.64. What is the ratio of the Number of total applications in Vietnam in 2004 to that in 2008?
Your response must be concise. 0.53. What is the ratio of the Number of total applications of Upper middle income in 2005 to that in 2006?
Your answer should be very brief. 0.91. What is the ratio of the Number of total applications in Macedonia in 2005 to that in 2006?
Ensure brevity in your answer.  0.98. What is the ratio of the Number of total applications of Vietnam in 2005 to that in 2006?
Your answer should be very brief. 0.79. What is the ratio of the Number of total applications in Upper middle income in 2005 to that in 2007?
Provide a succinct answer. 0.92. What is the ratio of the Number of total applications of Macedonia in 2005 to that in 2007?
Provide a short and direct response. 0.91. What is the ratio of the Number of total applications of Vietnam in 2005 to that in 2007?
Provide a succinct answer. 0.66. What is the ratio of the Number of total applications of Upper middle income in 2005 to that in 2008?
Ensure brevity in your answer.  0.91. What is the ratio of the Number of total applications of Macedonia in 2005 to that in 2008?
Make the answer very short. 0.79. What is the ratio of the Number of total applications in Vietnam in 2005 to that in 2008?
Provide a short and direct response. 0.63. What is the ratio of the Number of total applications in Upper middle income in 2006 to that in 2007?
Provide a short and direct response. 1.02. What is the ratio of the Number of total applications in Macedonia in 2006 to that in 2007?
Provide a short and direct response. 0.93. What is the ratio of the Number of total applications in Vietnam in 2006 to that in 2007?
Your answer should be compact. 0.83. What is the ratio of the Number of total applications in Macedonia in 2006 to that in 2008?
Make the answer very short. 0.8. What is the ratio of the Number of total applications of Vietnam in 2006 to that in 2008?
Make the answer very short. 0.8. What is the ratio of the Number of total applications of Macedonia in 2007 to that in 2008?
Keep it short and to the point. 0.87. What is the ratio of the Number of total applications of Vietnam in 2007 to that in 2008?
Provide a succinct answer. 0.96. What is the difference between the highest and the second highest Number of total applications of Upper middle income?
Your answer should be compact. 6140. What is the difference between the highest and the second highest Number of total applications in Macedonia?
Your response must be concise. 905. What is the difference between the highest and the second highest Number of total applications in Vietnam?
Make the answer very short. 1187. What is the difference between the highest and the lowest Number of total applications of Upper middle income?
Keep it short and to the point. 6.28e+05. What is the difference between the highest and the lowest Number of total applications in Macedonia?
Your answer should be compact. 2904. What is the difference between the highest and the lowest Number of total applications in Vietnam?
Provide a succinct answer. 2.39e+04. 